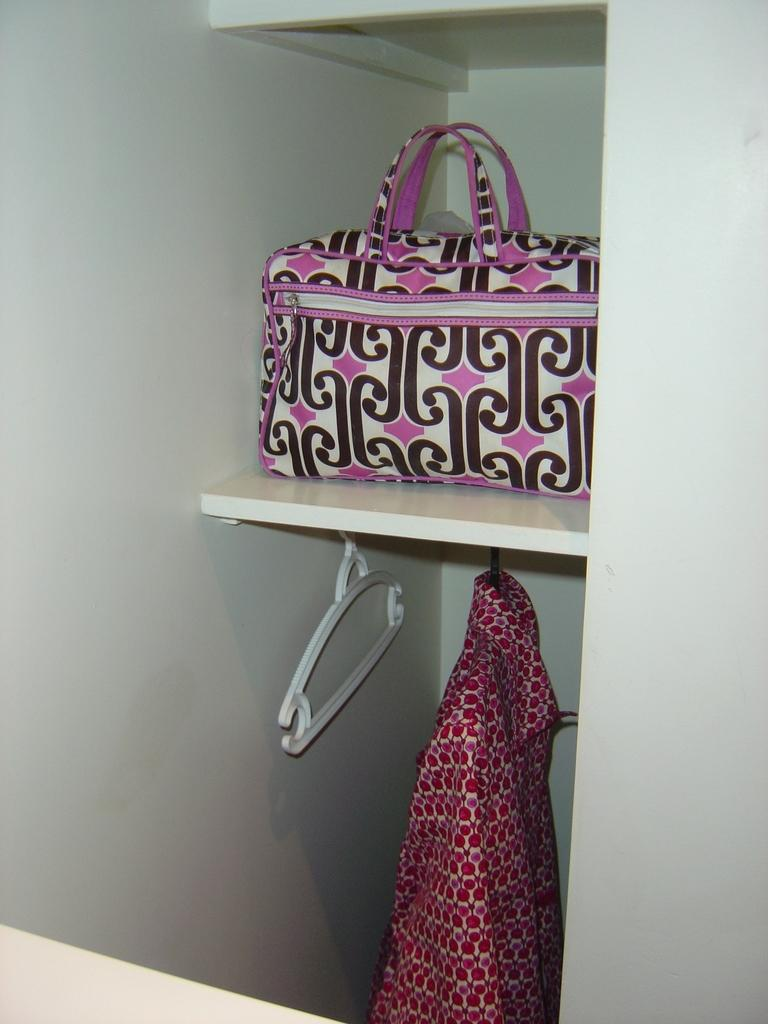What type of clothing item is in the image? There is a big shirt in the image. What is the shirt hanging on? There is a hanger in the image. Where is the hanger located? The hanger is in a cupboard. What type of soap is being used to clean the shirt in the image? There is no soap or cleaning activity depicted in the image; it only shows a big shirt hanging on a hanger in a cupboard. 